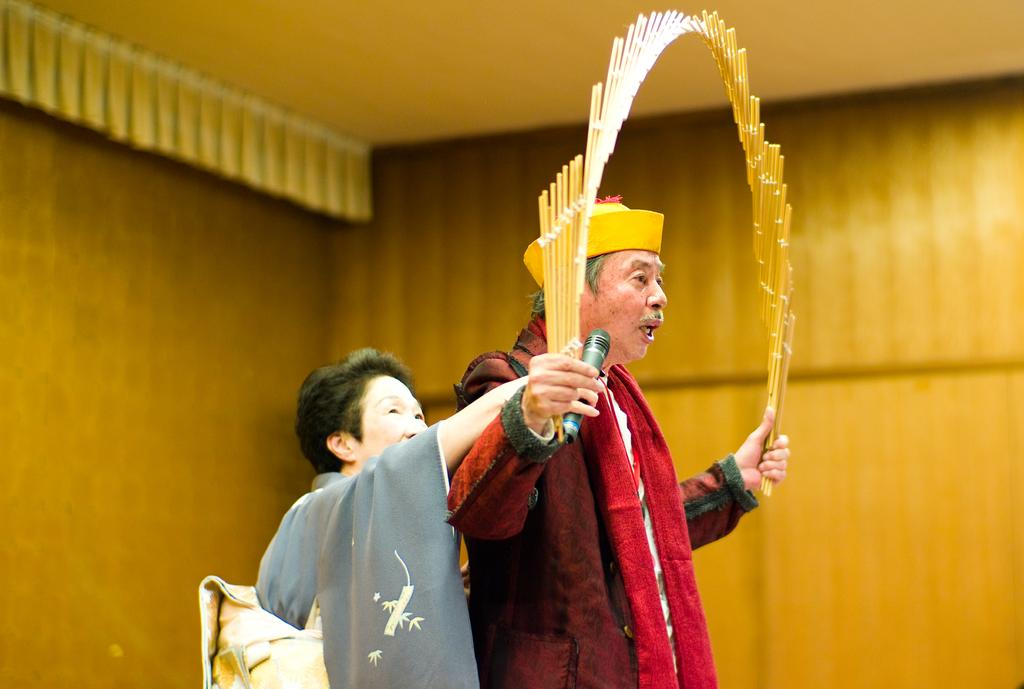How many people are in the image? There are two persons in the image. What is one person doing in the image? One person is holding a microphone. What is the other person holding in the image? The other person is holding an unspecified object. What can be seen in the background of the image? There is a wall in the background of the image. What language is the person holding the microphone speaking in the image? There is no information about the language being spoken in the image. Who is the owner of the unspecified object being held by the second person? There is no information about the ownership of the unspecified object in the image. 